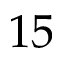Convert formula to latex. <formula><loc_0><loc_0><loc_500><loc_500>1 5</formula> 